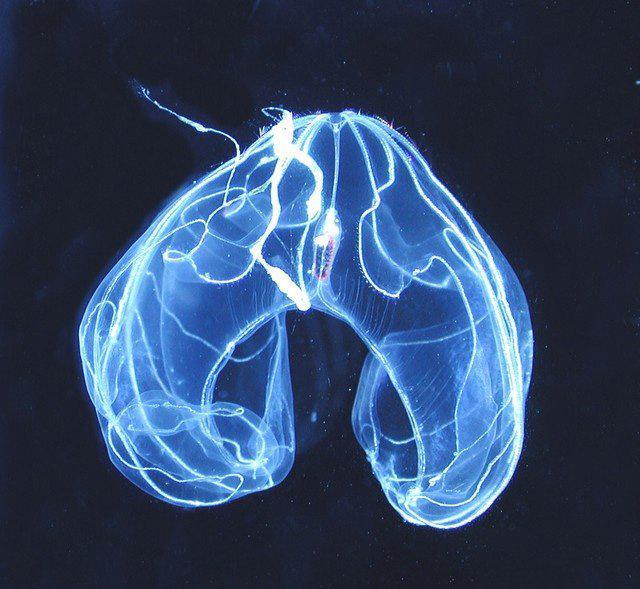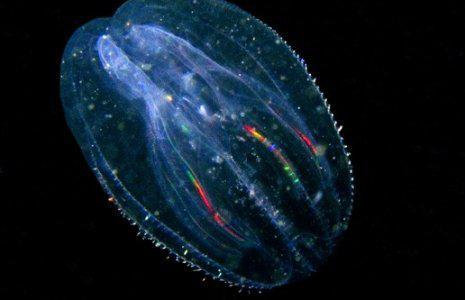The first image is the image on the left, the second image is the image on the right. Analyze the images presented: Is the assertion "Both images show jellyfish with trailing tentacles." valid? Answer yes or no. No. 